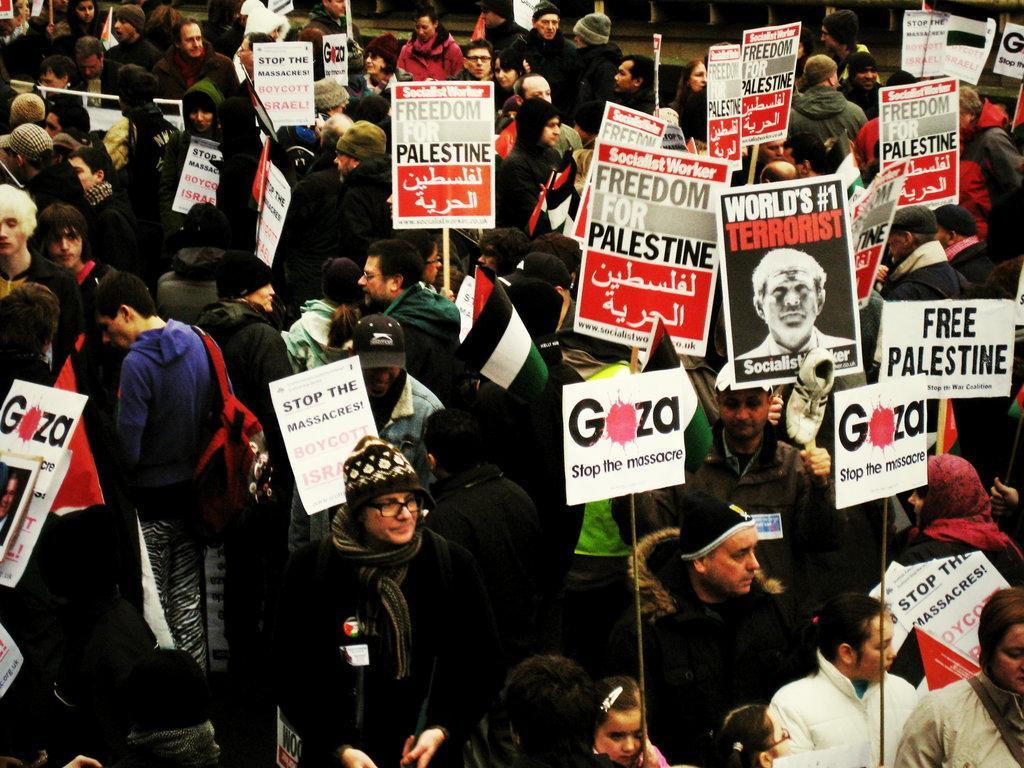Describe this image in one or two sentences. In this image there are a group of people who are standing and some of them are holding some placards, and on the placards there is some text written and some of them are holding some flags. 